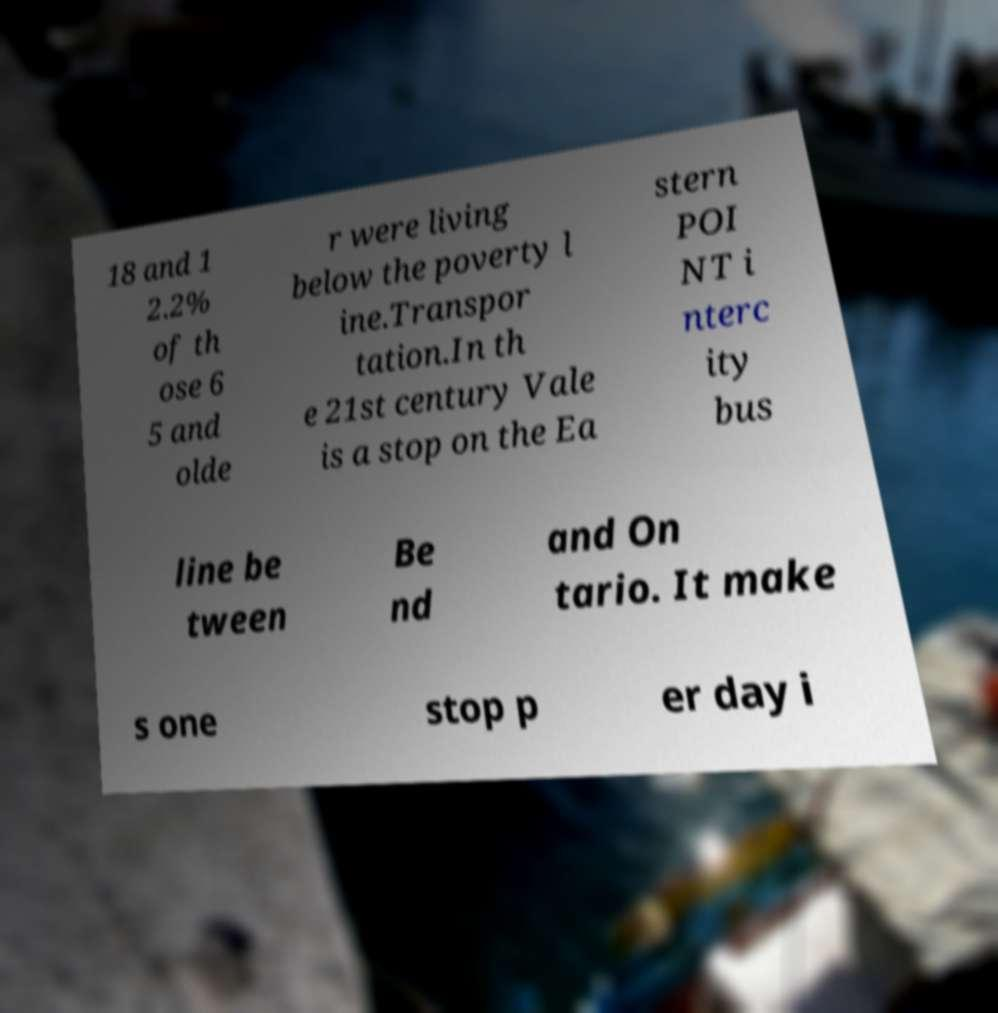Can you read and provide the text displayed in the image?This photo seems to have some interesting text. Can you extract and type it out for me? 18 and 1 2.2% of th ose 6 5 and olde r were living below the poverty l ine.Transpor tation.In th e 21st century Vale is a stop on the Ea stern POI NT i nterc ity bus line be tween Be nd and On tario. It make s one stop p er day i 